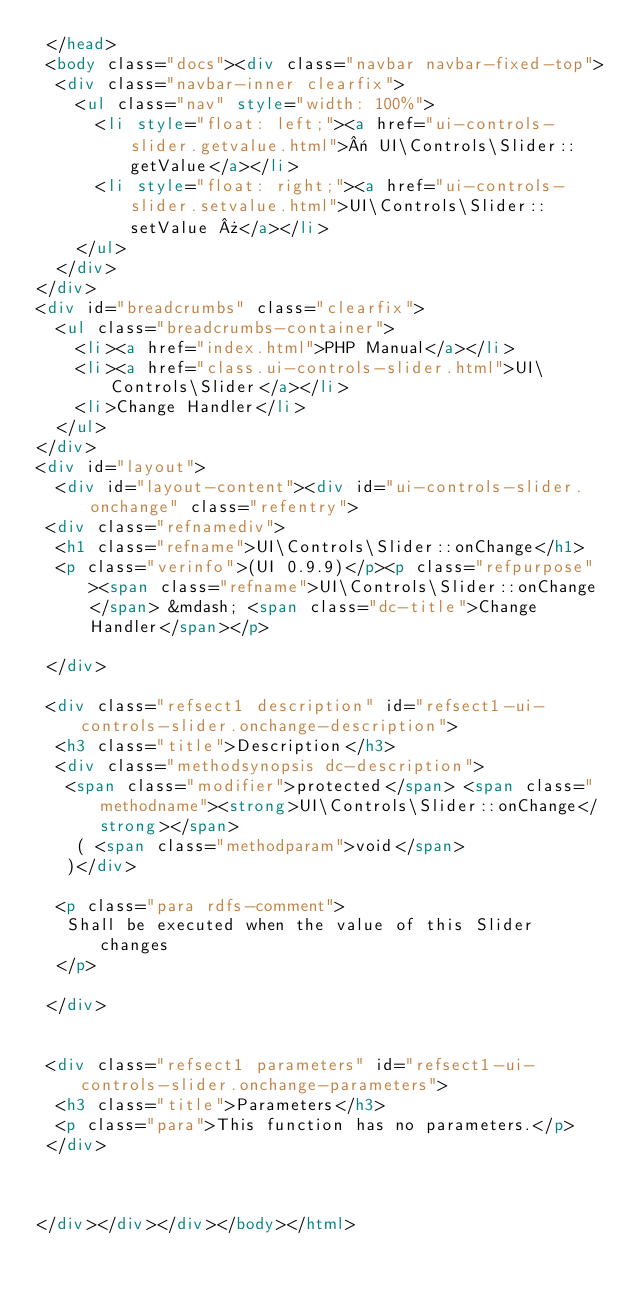<code> <loc_0><loc_0><loc_500><loc_500><_HTML_> </head>
 <body class="docs"><div class="navbar navbar-fixed-top">
  <div class="navbar-inner clearfix">
    <ul class="nav" style="width: 100%">
      <li style="float: left;"><a href="ui-controls-slider.getvalue.html">« UI\Controls\Slider::getValue</a></li>
      <li style="float: right;"><a href="ui-controls-slider.setvalue.html">UI\Controls\Slider::setValue »</a></li>
    </ul>
  </div>
</div>
<div id="breadcrumbs" class="clearfix">
  <ul class="breadcrumbs-container">
    <li><a href="index.html">PHP Manual</a></li>
    <li><a href="class.ui-controls-slider.html">UI\Controls\Slider</a></li>
    <li>Change Handler</li>
  </ul>
</div>
<div id="layout">
  <div id="layout-content"><div id="ui-controls-slider.onchange" class="refentry">
 <div class="refnamediv">
  <h1 class="refname">UI\Controls\Slider::onChange</h1>
  <p class="verinfo">(UI 0.9.9)</p><p class="refpurpose"><span class="refname">UI\Controls\Slider::onChange</span> &mdash; <span class="dc-title">Change Handler</span></p>

 </div>

 <div class="refsect1 description" id="refsect1-ui-controls-slider.onchange-description">
  <h3 class="title">Description</h3>
  <div class="methodsynopsis dc-description">
   <span class="modifier">protected</span> <span class="methodname"><strong>UI\Controls\Slider::onChange</strong></span>
    ( <span class="methodparam">void</span>
   )</div>

  <p class="para rdfs-comment">
   Shall be executed when the value of this Slider changes
  </p>

 </div>


 <div class="refsect1 parameters" id="refsect1-ui-controls-slider.onchange-parameters">
  <h3 class="title">Parameters</h3>
  <p class="para">This function has no parameters.</p>
 </div>



</div></div></div></body></html></code> 